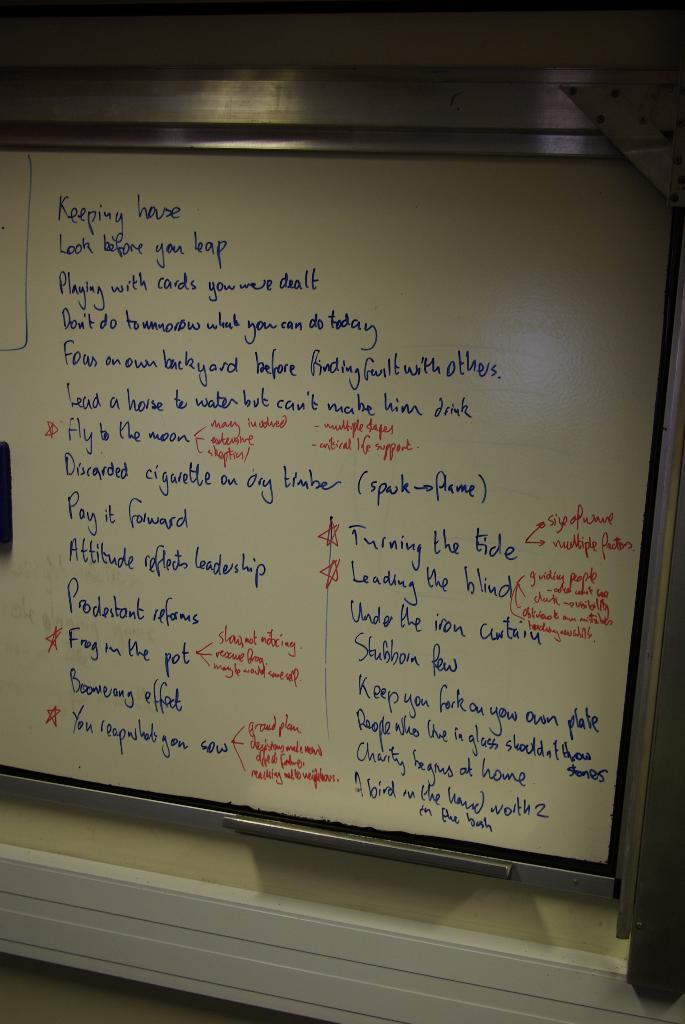What is the topic of the notes?
Offer a very short reply. Keeping house. 